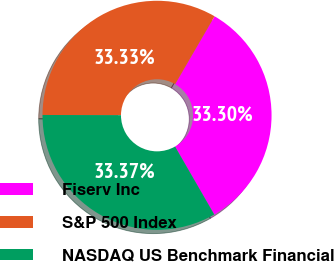Convert chart to OTSL. <chart><loc_0><loc_0><loc_500><loc_500><pie_chart><fcel>Fiserv Inc<fcel>S&P 500 Index<fcel>NASDAQ US Benchmark Financial<nl><fcel>33.3%<fcel>33.33%<fcel>33.37%<nl></chart> 